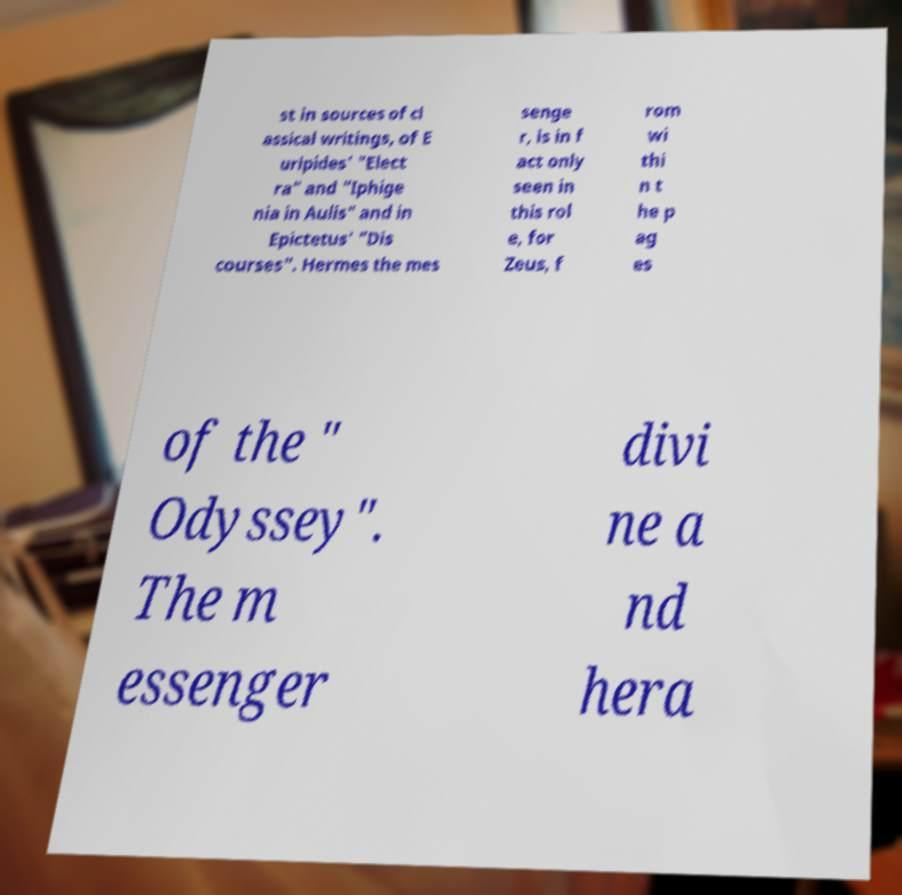Could you extract and type out the text from this image? st in sources of cl assical writings, of E uripides' "Elect ra" and "Iphige nia in Aulis" and in Epictetus' "Dis courses". Hermes the mes senge r, is in f act only seen in this rol e, for Zeus, f rom wi thi n t he p ag es of the " Odyssey". The m essenger divi ne a nd hera 